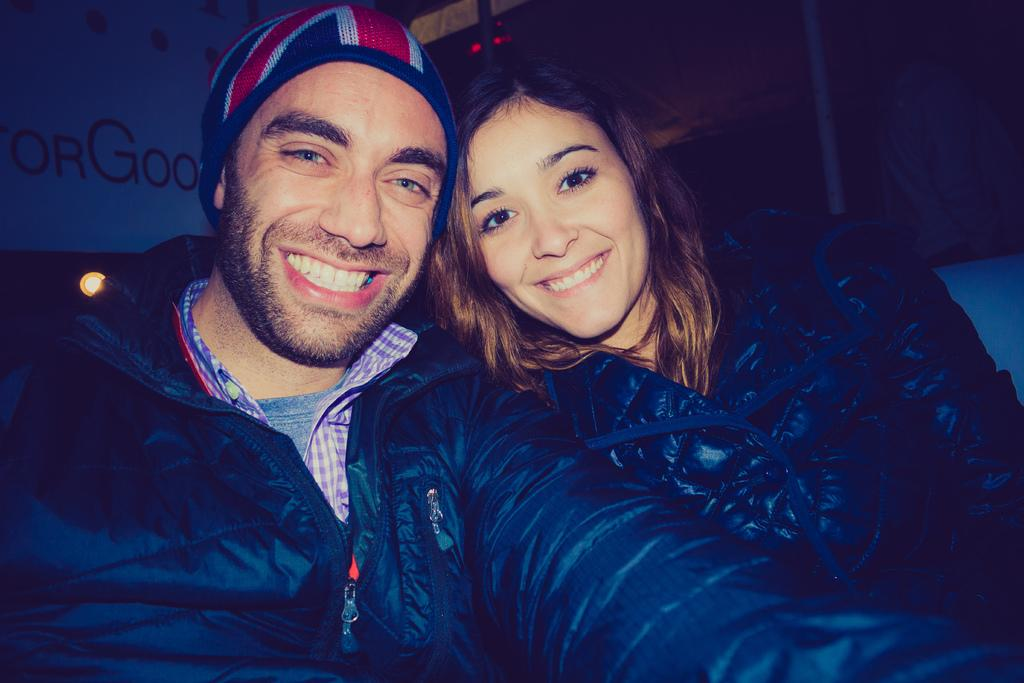How many people are in the image? There are two persons in the image. What are the people wearing? Both persons are wearing black color jackets. What is the facial expression of the people in the image? The persons are smiling. Where can a wall poster be seen in the image? The wall poster is visible in the image, located at the top left side. What type of sheet is being used by the persons in the image? There is no sheet present in the image; the persons are wearing jackets. Can you recite the verse written on the wall poster in the image? There is no verse visible on the wall poster in the image; only the image itself can be seen. 